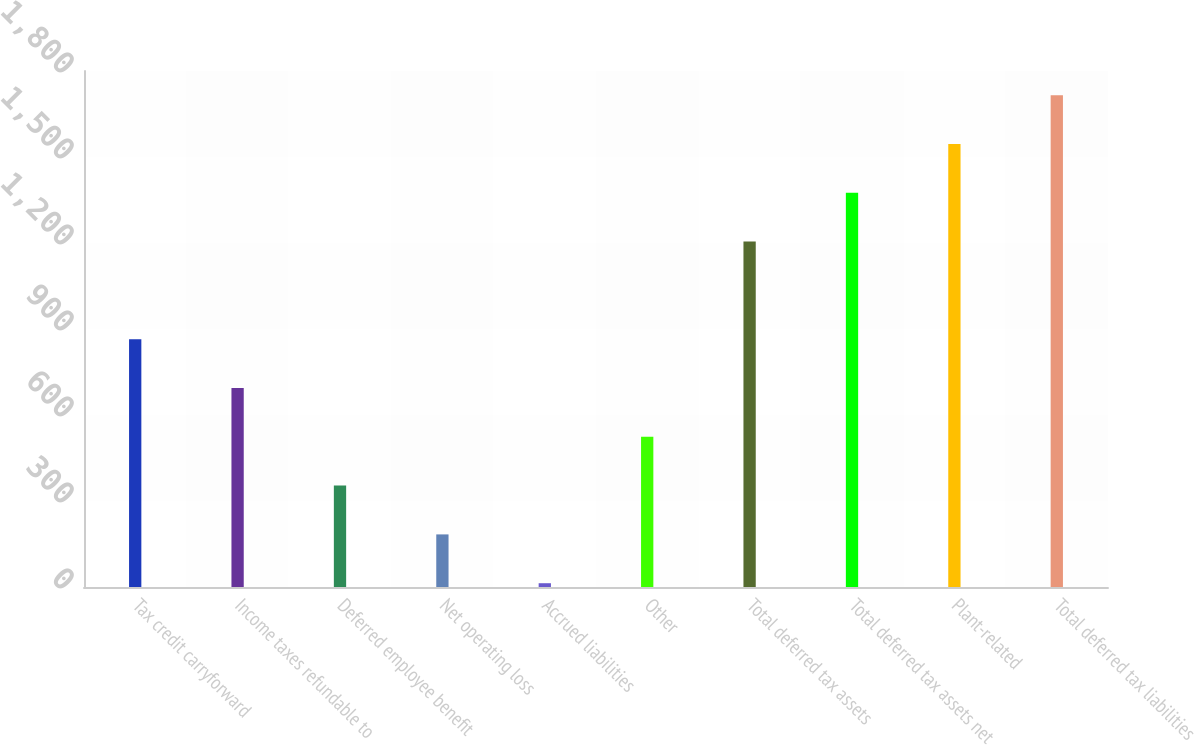Convert chart. <chart><loc_0><loc_0><loc_500><loc_500><bar_chart><fcel>Tax credit carryforward<fcel>Income taxes refundable to<fcel>Deferred employee benefit<fcel>Net operating loss<fcel>Accrued liabilities<fcel>Other<fcel>Total deferred tax assets<fcel>Total deferred tax assets net<fcel>Plant-related<fcel>Total deferred tax liabilities<nl><fcel>864.45<fcel>694.2<fcel>353.7<fcel>183.45<fcel>13.2<fcel>523.95<fcel>1204.95<fcel>1375.2<fcel>1545.45<fcel>1715.7<nl></chart> 